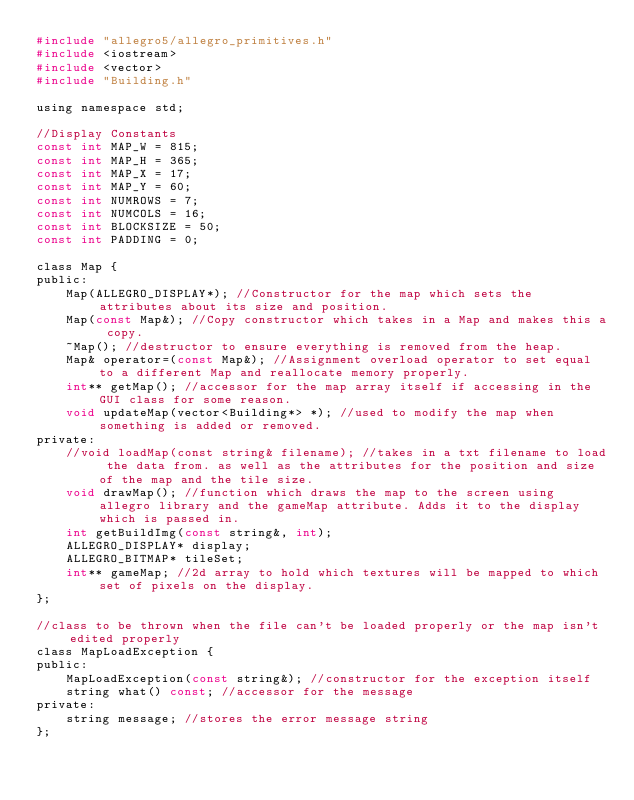<code> <loc_0><loc_0><loc_500><loc_500><_C_>#include "allegro5/allegro_primitives.h"
#include <iostream>
#include <vector>
#include "Building.h"

using namespace std;

//Display Constants
const int MAP_W = 815;
const int MAP_H = 365;
const int MAP_X = 17;
const int MAP_Y = 60;
const int NUMROWS = 7;
const int NUMCOLS = 16;
const int BLOCKSIZE = 50;
const int PADDING = 0;

class Map {
public:
    Map(ALLEGRO_DISPLAY*); //Constructor for the map which sets the attributes about its size and position.
    Map(const Map&); //Copy constructor which takes in a Map and makes this a copy.
    ~Map(); //destructor to ensure everything is removed from the heap.
    Map& operator=(const Map&); //Assignment overload operator to set equal to a different Map and reallocate memory properly.
    int** getMap(); //accessor for the map array itself if accessing in the GUI class for some reason.
    void updateMap(vector<Building*> *); //used to modify the map when something is added or removed.
private:
    //void loadMap(const string& filename); //takes in a txt filename to load the data from. as well as the attributes for the position and size of the map and the tile size.
    void drawMap(); //function which draws the map to the screen using allegro library and the gameMap attribute. Adds it to the display which is passed in.
    int getBuildImg(const string&, int);
    ALLEGRO_DISPLAY* display;
    ALLEGRO_BITMAP* tileSet;
    int** gameMap; //2d array to hold which textures will be mapped to which set of pixels on the display.
};

//class to be thrown when the file can't be loaded properly or the map isn't edited properly
class MapLoadException {
public:
    MapLoadException(const string&); //constructor for the exception itself
    string what() const; //accessor for the message
private:
    string message; //stores the error message string
};
</code> 